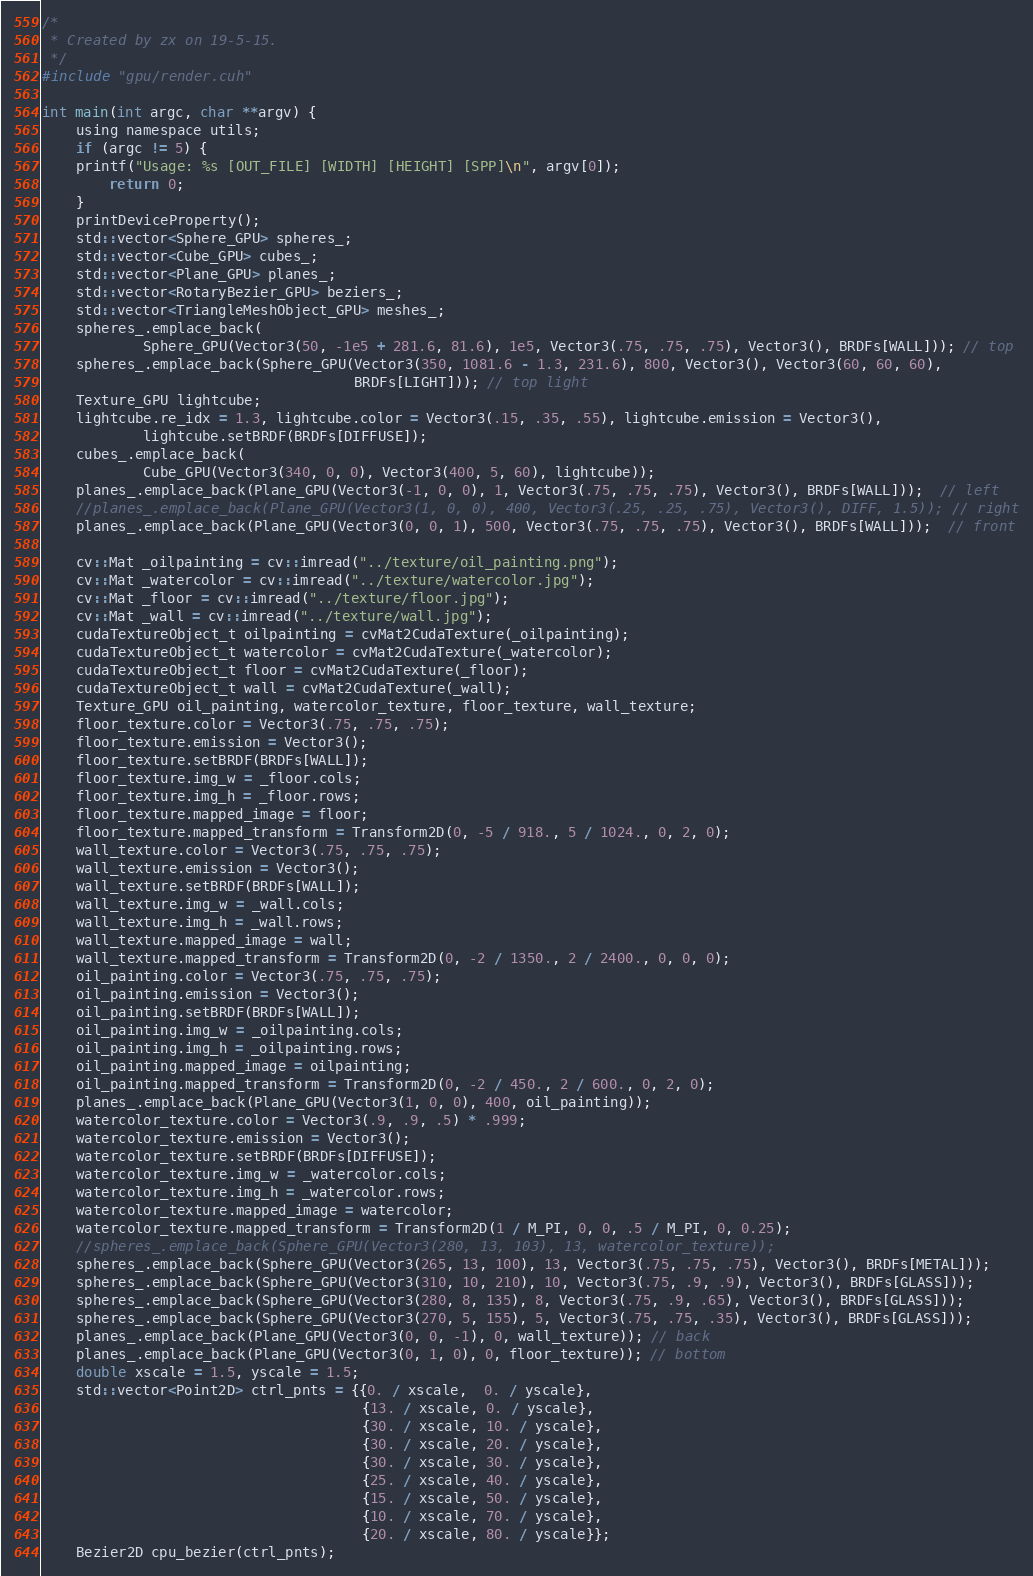<code> <loc_0><loc_0><loc_500><loc_500><_Cuda_>/*
 * Created by zx on 19-5-15.
 */
#include "gpu/render.cuh"

int main(int argc, char **argv) {
    using namespace utils;
    if (argc != 5) {
	printf("Usage: %s [OUT_FILE] [WIDTH] [HEIGHT] [SPP]\n", argv[0]);
        return 0;
    }
    printDeviceProperty();
    std::vector<Sphere_GPU> spheres_;
    std::vector<Cube_GPU> cubes_;
    std::vector<Plane_GPU> planes_;
    std::vector<RotaryBezier_GPU> beziers_;
    std::vector<TriangleMeshObject_GPU> meshes_;
    spheres_.emplace_back(
            Sphere_GPU(Vector3(50, -1e5 + 281.6, 81.6), 1e5, Vector3(.75, .75, .75), Vector3(), BRDFs[WALL])); // top
    spheres_.emplace_back(Sphere_GPU(Vector3(350, 1081.6 - 1.3, 231.6), 800, Vector3(), Vector3(60, 60, 60),
                                     BRDFs[LIGHT])); // top light
    Texture_GPU lightcube;
    lightcube.re_idx = 1.3, lightcube.color = Vector3(.15, .35, .55), lightcube.emission = Vector3(),
            lightcube.setBRDF(BRDFs[DIFFUSE]);
    cubes_.emplace_back(
            Cube_GPU(Vector3(340, 0, 0), Vector3(400, 5, 60), lightcube));
    planes_.emplace_back(Plane_GPU(Vector3(-1, 0, 0), 1, Vector3(.75, .75, .75), Vector3(), BRDFs[WALL]));  // left
    //planes_.emplace_back(Plane_GPU(Vector3(1, 0, 0), 400, Vector3(.25, .25, .75), Vector3(), DIFF, 1.5)); // right
    planes_.emplace_back(Plane_GPU(Vector3(0, 0, 1), 500, Vector3(.75, .75, .75), Vector3(), BRDFs[WALL]));  // front
    
    cv::Mat _oilpainting = cv::imread("../texture/oil_painting.png");
    cv::Mat _watercolor = cv::imread("../texture/watercolor.jpg");
    cv::Mat _floor = cv::imread("../texture/floor.jpg");
    cv::Mat _wall = cv::imread("../texture/wall.jpg");
    cudaTextureObject_t oilpainting = cvMat2CudaTexture(_oilpainting);
    cudaTextureObject_t watercolor = cvMat2CudaTexture(_watercolor);
    cudaTextureObject_t floor = cvMat2CudaTexture(_floor);
    cudaTextureObject_t wall = cvMat2CudaTexture(_wall);
    Texture_GPU oil_painting, watercolor_texture, floor_texture, wall_texture;
    floor_texture.color = Vector3(.75, .75, .75);
    floor_texture.emission = Vector3();
    floor_texture.setBRDF(BRDFs[WALL]);
    floor_texture.img_w = _floor.cols;
    floor_texture.img_h = _floor.rows;
    floor_texture.mapped_image = floor;
    floor_texture.mapped_transform = Transform2D(0, -5 / 918., 5 / 1024., 0, 2, 0);
    wall_texture.color = Vector3(.75, .75, .75);
    wall_texture.emission = Vector3();
    wall_texture.setBRDF(BRDFs[WALL]);
    wall_texture.img_w = _wall.cols;
    wall_texture.img_h = _wall.rows;
    wall_texture.mapped_image = wall;
    wall_texture.mapped_transform = Transform2D(0, -2 / 1350., 2 / 2400., 0, 0, 0);
    oil_painting.color = Vector3(.75, .75, .75);
    oil_painting.emission = Vector3();
    oil_painting.setBRDF(BRDFs[WALL]);
    oil_painting.img_w = _oilpainting.cols;
    oil_painting.img_h = _oilpainting.rows;
    oil_painting.mapped_image = oilpainting;
    oil_painting.mapped_transform = Transform2D(0, -2 / 450., 2 / 600., 0, 2, 0);
    planes_.emplace_back(Plane_GPU(Vector3(1, 0, 0), 400, oil_painting));
    watercolor_texture.color = Vector3(.9, .9, .5) * .999;
    watercolor_texture.emission = Vector3();
    watercolor_texture.setBRDF(BRDFs[DIFFUSE]);
    watercolor_texture.img_w = _watercolor.cols;
    watercolor_texture.img_h = _watercolor.rows;
    watercolor_texture.mapped_image = watercolor;
    watercolor_texture.mapped_transform = Transform2D(1 / M_PI, 0, 0, .5 / M_PI, 0, 0.25);
    //spheres_.emplace_back(Sphere_GPU(Vector3(280, 13, 103), 13, watercolor_texture));
    spheres_.emplace_back(Sphere_GPU(Vector3(265, 13, 100), 13, Vector3(.75, .75, .75), Vector3(), BRDFs[METAL]));
    spheres_.emplace_back(Sphere_GPU(Vector3(310, 10, 210), 10, Vector3(.75, .9, .9), Vector3(), BRDFs[GLASS]));
    spheres_.emplace_back(Sphere_GPU(Vector3(280, 8, 135), 8, Vector3(.75, .9, .65), Vector3(), BRDFs[GLASS]));
    spheres_.emplace_back(Sphere_GPU(Vector3(270, 5, 155), 5, Vector3(.75, .75, .35), Vector3(), BRDFs[GLASS]));
    planes_.emplace_back(Plane_GPU(Vector3(0, 0, -1), 0, wall_texture)); // back
    planes_.emplace_back(Plane_GPU(Vector3(0, 1, 0), 0, floor_texture)); // bottom
    double xscale = 1.5, yscale = 1.5;
    std::vector<Point2D> ctrl_pnts = {{0. / xscale,  0. / yscale},
                                      {13. / xscale, 0. / yscale},
                                      {30. / xscale, 10. / yscale},
                                      {30. / xscale, 20. / yscale},
                                      {30. / xscale, 30. / yscale},
                                      {25. / xscale, 40. / yscale},
                                      {15. / xscale, 50. / yscale},
                                      {10. / xscale, 70. / yscale},
                                      {20. / xscale, 80. / yscale}};
    Bezier2D cpu_bezier(ctrl_pnts);
</code> 